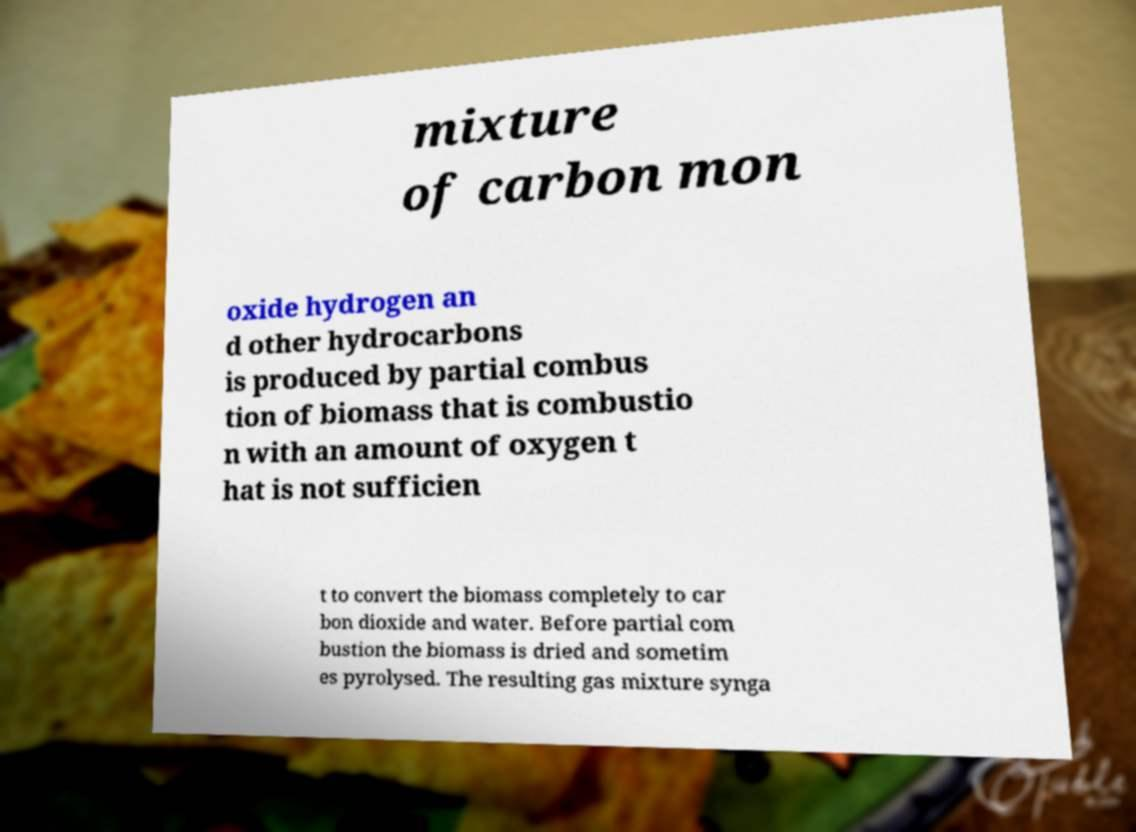For documentation purposes, I need the text within this image transcribed. Could you provide that? mixture of carbon mon oxide hydrogen an d other hydrocarbons is produced by partial combus tion of biomass that is combustio n with an amount of oxygen t hat is not sufficien t to convert the biomass completely to car bon dioxide and water. Before partial com bustion the biomass is dried and sometim es pyrolysed. The resulting gas mixture synga 